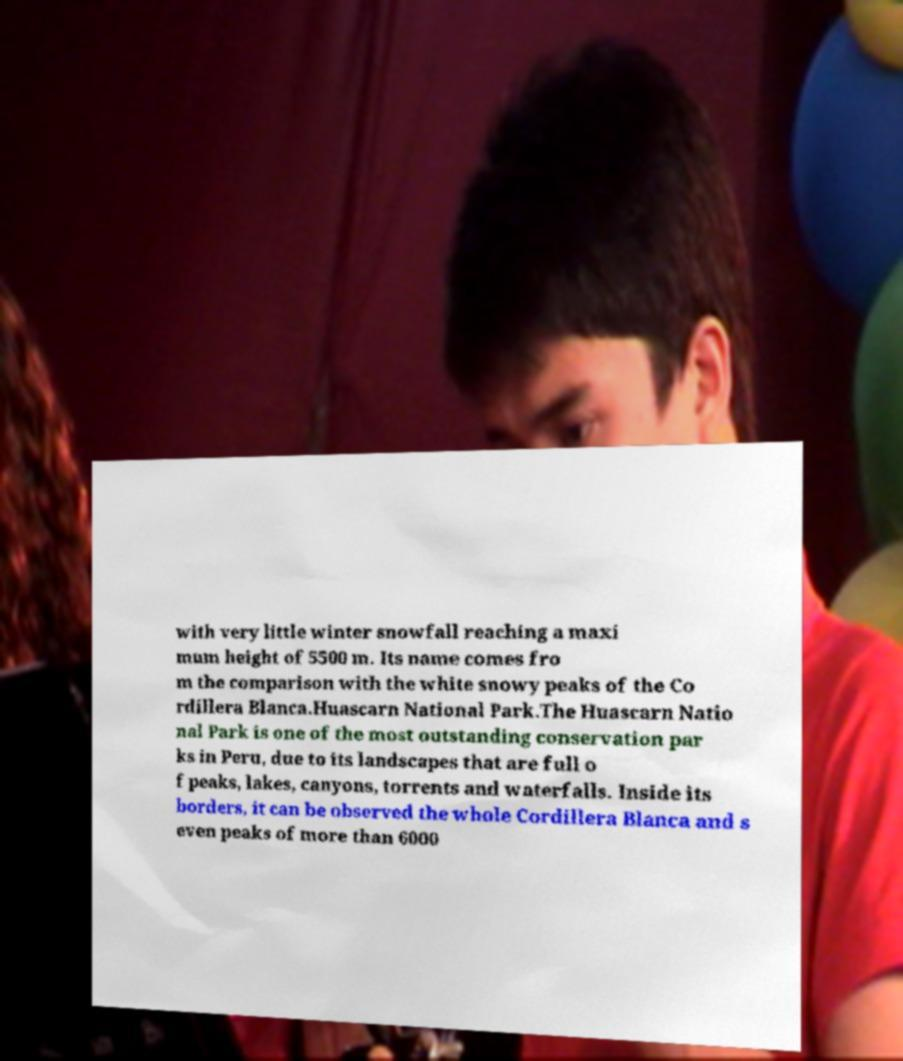For documentation purposes, I need the text within this image transcribed. Could you provide that? with very little winter snowfall reaching a maxi mum height of 5500 m. Its name comes fro m the comparison with the white snowy peaks of the Co rdillera Blanca.Huascarn National Park.The Huascarn Natio nal Park is one of the most outstanding conservation par ks in Peru, due to its landscapes that are full o f peaks, lakes, canyons, torrents and waterfalls. Inside its borders, it can be observed the whole Cordillera Blanca and s even peaks of more than 6000 